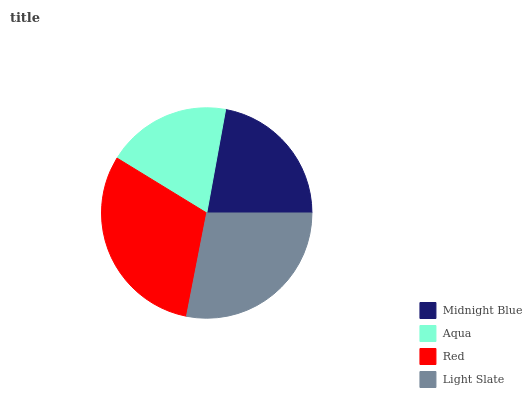Is Aqua the minimum?
Answer yes or no. Yes. Is Red the maximum?
Answer yes or no. Yes. Is Red the minimum?
Answer yes or no. No. Is Aqua the maximum?
Answer yes or no. No. Is Red greater than Aqua?
Answer yes or no. Yes. Is Aqua less than Red?
Answer yes or no. Yes. Is Aqua greater than Red?
Answer yes or no. No. Is Red less than Aqua?
Answer yes or no. No. Is Light Slate the high median?
Answer yes or no. Yes. Is Midnight Blue the low median?
Answer yes or no. Yes. Is Red the high median?
Answer yes or no. No. Is Aqua the low median?
Answer yes or no. No. 